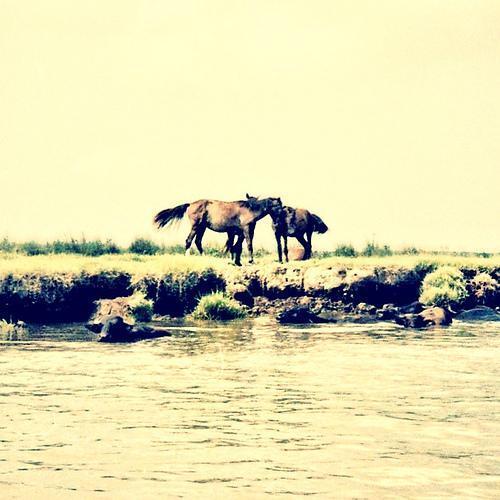How many horses are there?
Give a very brief answer. 2. 